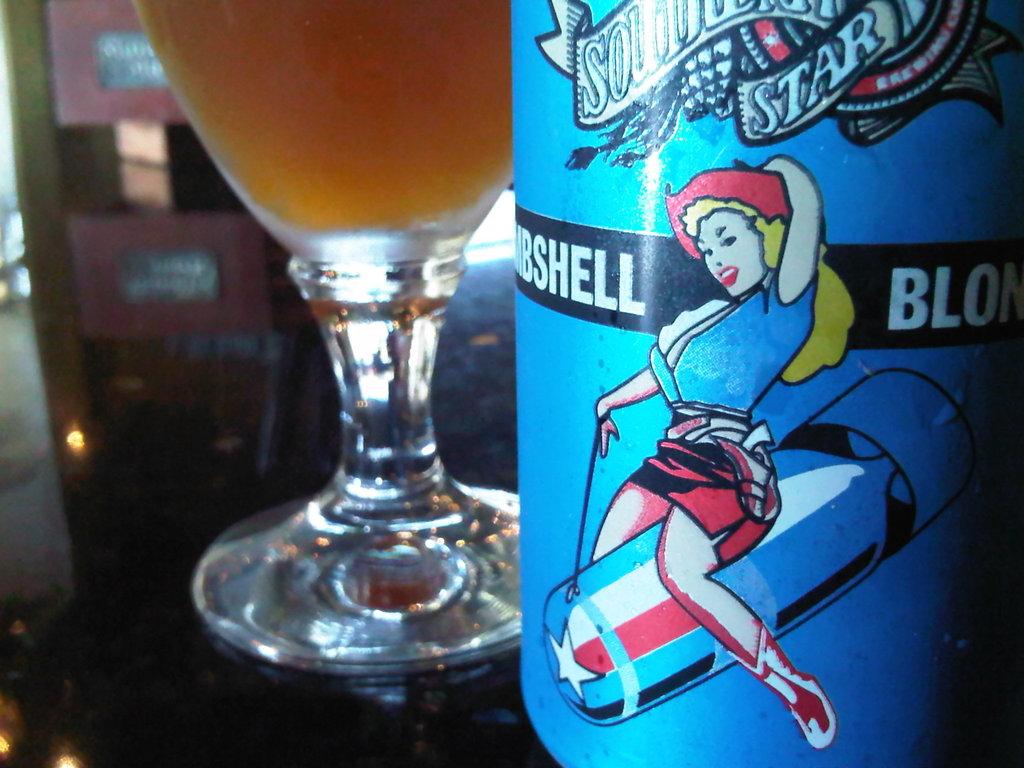What is one letter found to the left of the woman on the bottle?
Provide a succinct answer. L. 